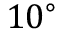<formula> <loc_0><loc_0><loc_500><loc_500>1 0 ^ { \circ }</formula> 